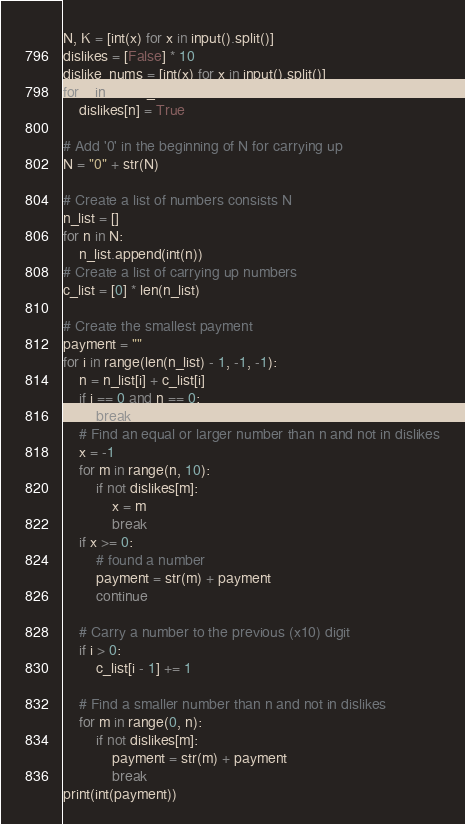Convert code to text. <code><loc_0><loc_0><loc_500><loc_500><_Python_>N, K = [int(x) for x in input().split()]
dislikes = [False] * 10
dislike_nums = [int(x) for x in input().split()]
for n in dislike_nums:
    dislikes[n] = True

# Add '0' in the beginning of N for carrying up
N = "0" + str(N)

# Create a list of numbers consists N
n_list = []
for n in N:
    n_list.append(int(n))
# Create a list of carrying up numbers
c_list = [0] * len(n_list)

# Create the smallest payment
payment = ""
for i in range(len(n_list) - 1, -1, -1):
    n = n_list[i] + c_list[i]
    if i == 0 and n == 0:
        break
    # Find an equal or larger number than n and not in dislikes
    x = -1
    for m in range(n, 10):
        if not dislikes[m]:
            x = m
            break
    if x >= 0:
        # found a number
        payment = str(m) + payment
        continue

    # Carry a number to the previous (x10) digit
    if i > 0:
        c_list[i - 1] += 1

    # Find a smaller number than n and not in dislikes
    for m in range(0, n):
        if not dislikes[m]:
            payment = str(m) + payment
            break
print(int(payment))</code> 